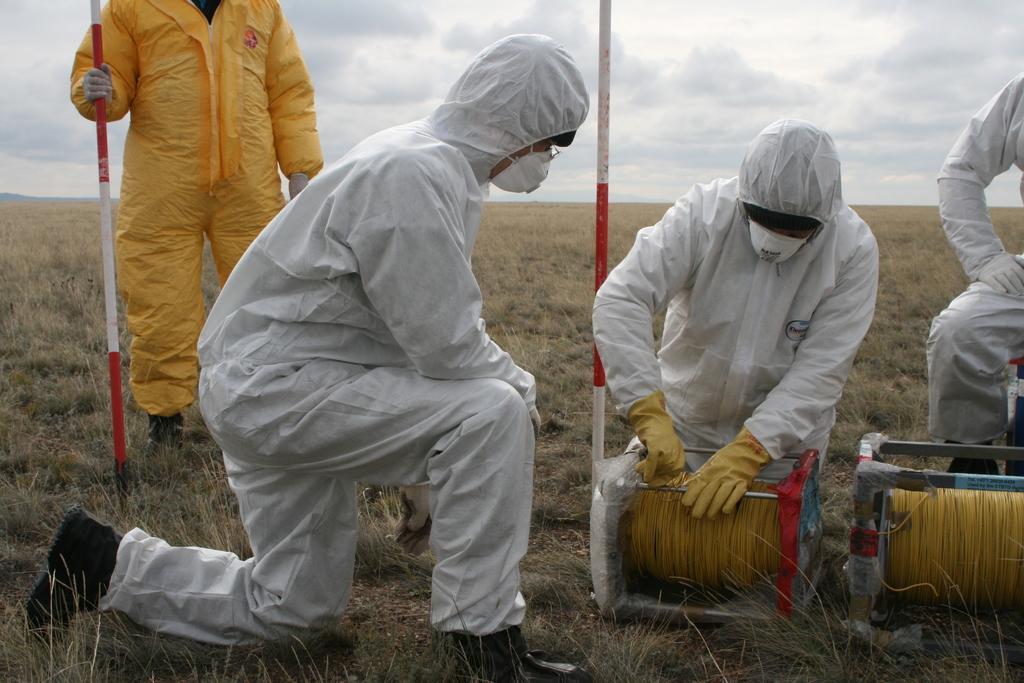Please provide a concise description of this image. In this picture I can see a person holding stick on the left side. I can see the wire rollers. I can see people. I can see clouds in the sky. I can see the grass. 